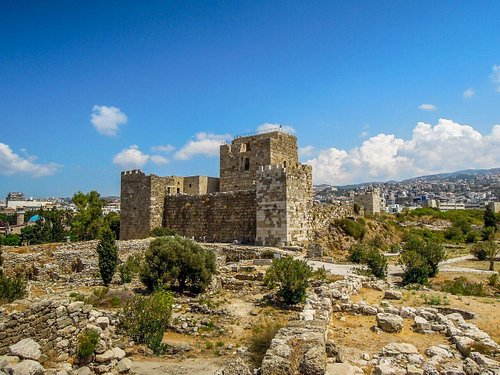How have these ruins impacted modern Byblos? The ruins significantly influence the cultural and educational aspects of modern Byblos, drawing tourists and historians from around the world, which boosts the local economy. Moreover, they serve as a constant reminder of the city's historical depth and legacy, influencing local architecture and preservation efforts, ensuring that the city's past is integrated into its present and future development. 